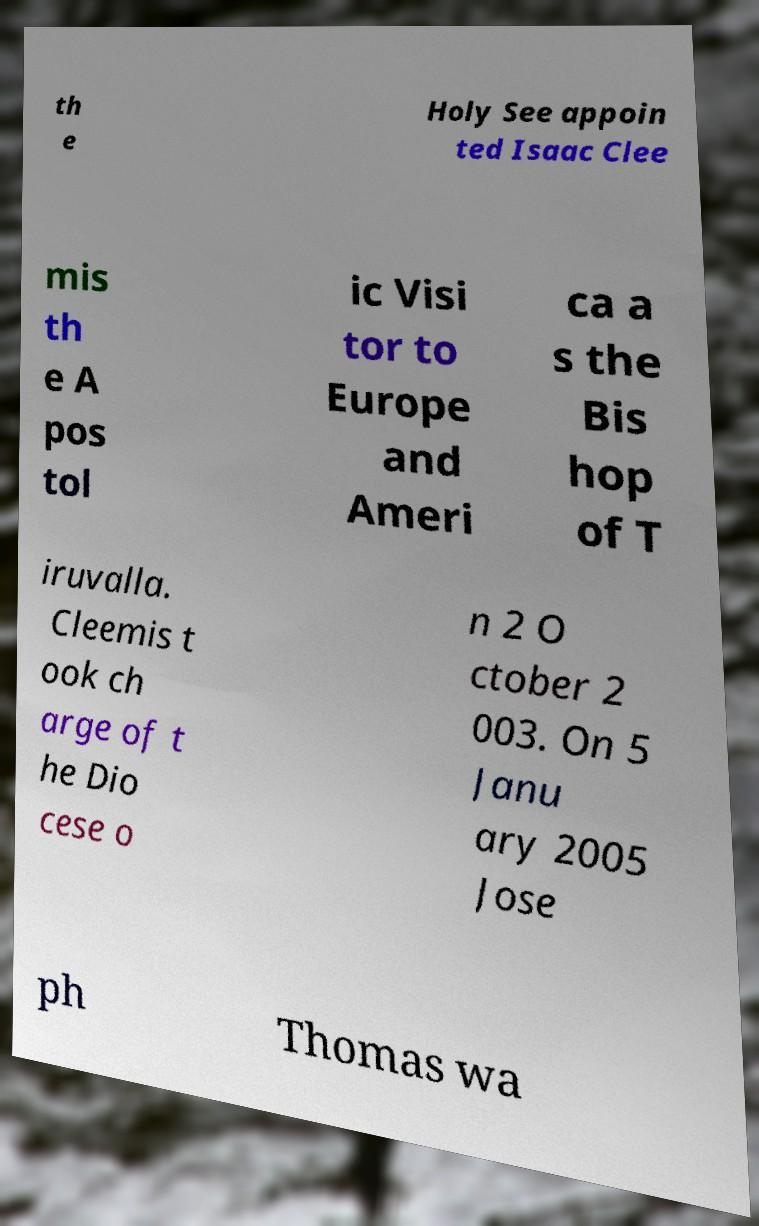Please read and relay the text visible in this image. What does it say? th e Holy See appoin ted Isaac Clee mis th e A pos tol ic Visi tor to Europe and Ameri ca a s the Bis hop of T iruvalla. Cleemis t ook ch arge of t he Dio cese o n 2 O ctober 2 003. On 5 Janu ary 2005 Jose ph Thomas wa 